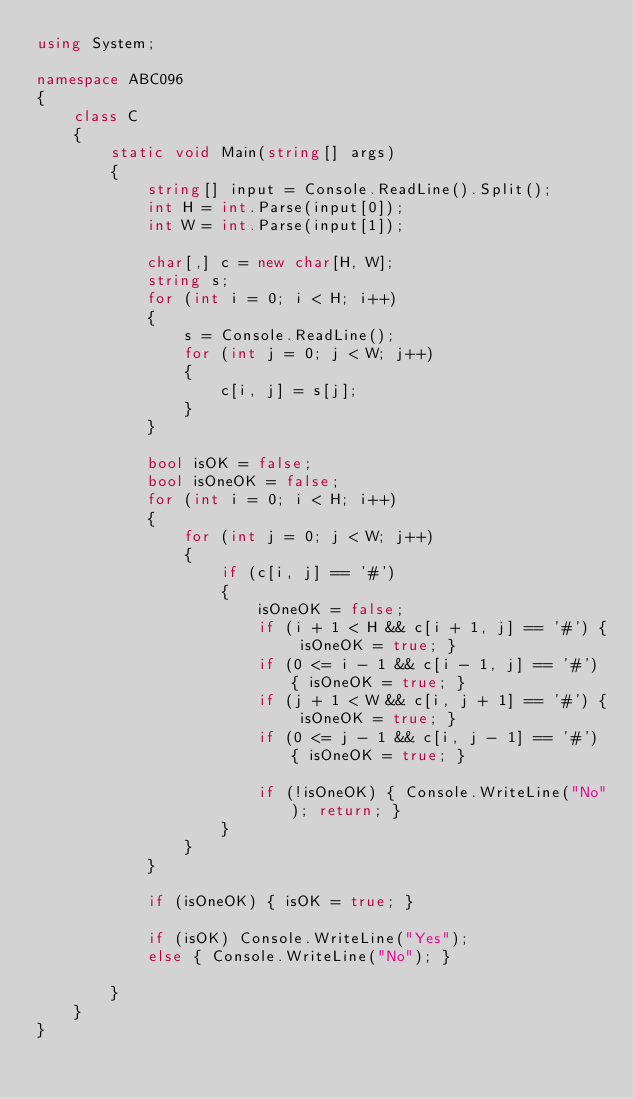Convert code to text. <code><loc_0><loc_0><loc_500><loc_500><_C#_>using System;

namespace ABC096
{
    class C
    {
        static void Main(string[] args)
        {
            string[] input = Console.ReadLine().Split();
            int H = int.Parse(input[0]);
            int W = int.Parse(input[1]);

            char[,] c = new char[H, W];
            string s;
            for (int i = 0; i < H; i++)
            {
                s = Console.ReadLine();
                for (int j = 0; j < W; j++)
                {
                    c[i, j] = s[j];
                }
            }

            bool isOK = false;
            bool isOneOK = false;
            for (int i = 0; i < H; i++)
            {
                for (int j = 0; j < W; j++)
                {
                    if (c[i, j] == '#')
                    {
                        isOneOK = false;
                        if (i + 1 < H && c[i + 1, j] == '#') { isOneOK = true; }
                        if (0 <= i - 1 && c[i - 1, j] == '#') { isOneOK = true; }
                        if (j + 1 < W && c[i, j + 1] == '#') { isOneOK = true; }
                        if (0 <= j - 1 && c[i, j - 1] == '#') { isOneOK = true; }

                        if (!isOneOK) { Console.WriteLine("No"); return; }
                    }
                }
            }

            if (isOneOK) { isOK = true; }

            if (isOK) Console.WriteLine("Yes");
            else { Console.WriteLine("No"); }

        }
    }
}
</code> 